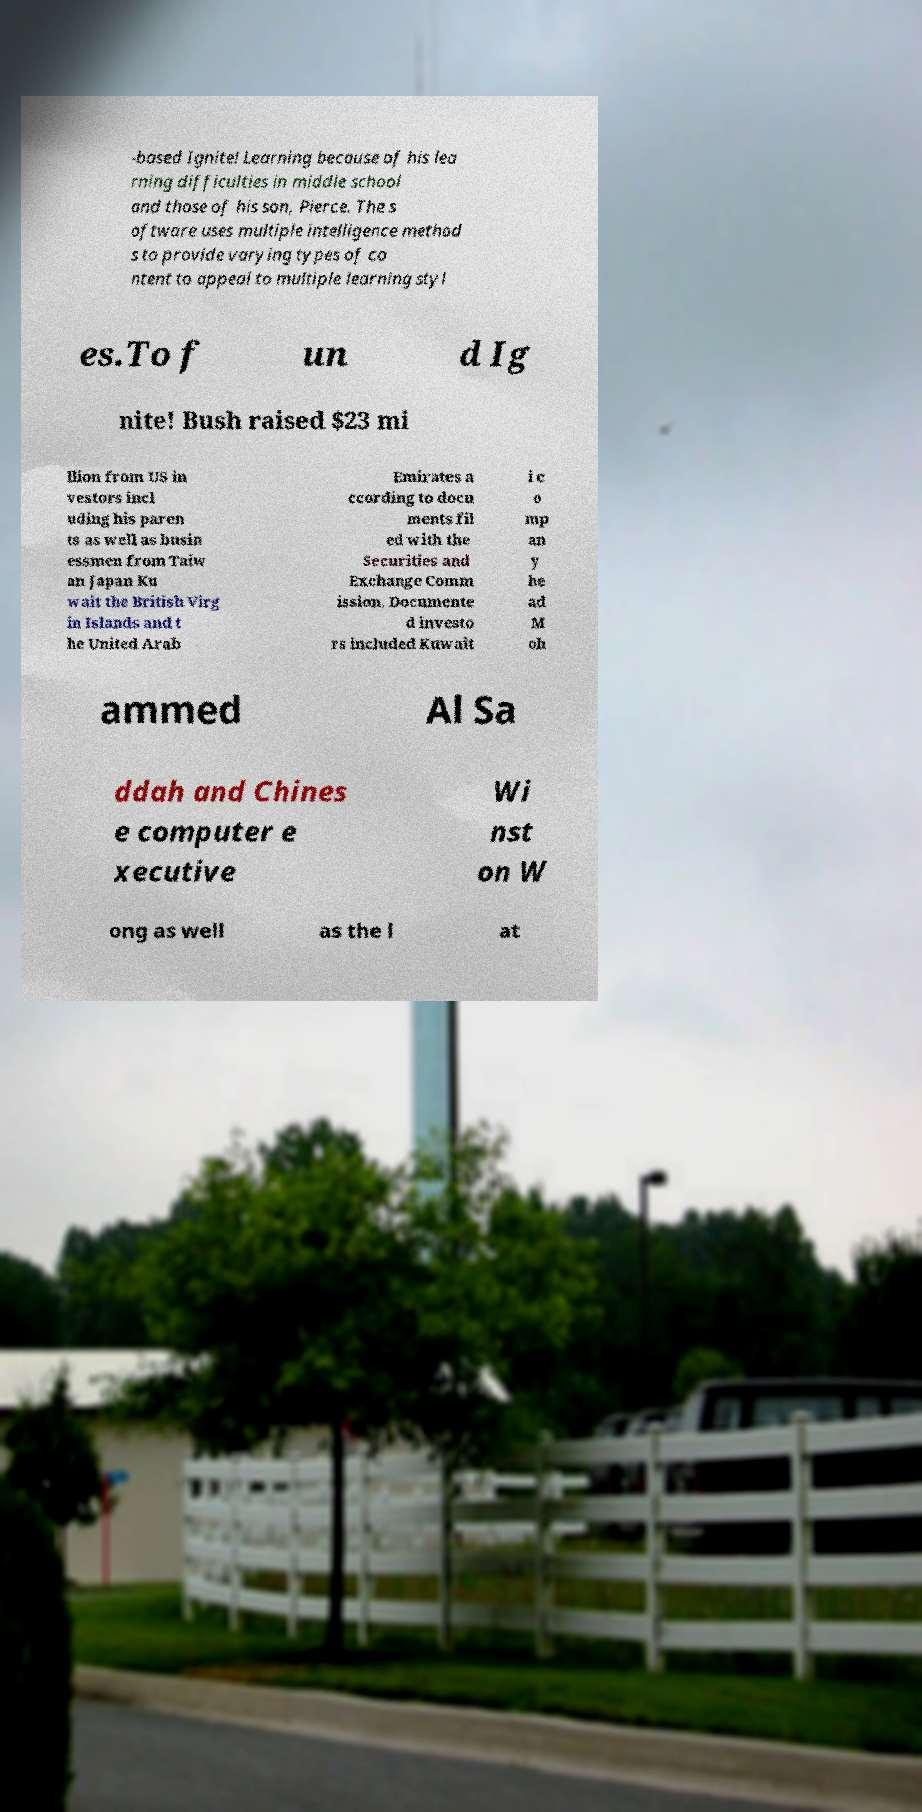Please read and relay the text visible in this image. What does it say? -based Ignite! Learning because of his lea rning difficulties in middle school and those of his son, Pierce. The s oftware uses multiple intelligence method s to provide varying types of co ntent to appeal to multiple learning styl es.To f un d Ig nite! Bush raised $23 mi llion from US in vestors incl uding his paren ts as well as busin essmen from Taiw an Japan Ku wait the British Virg in Islands and t he United Arab Emirates a ccording to docu ments fil ed with the Securities and Exchange Comm ission. Documente d investo rs included Kuwait i c o mp an y he ad M oh ammed Al Sa ddah and Chines e computer e xecutive Wi nst on W ong as well as the l at 